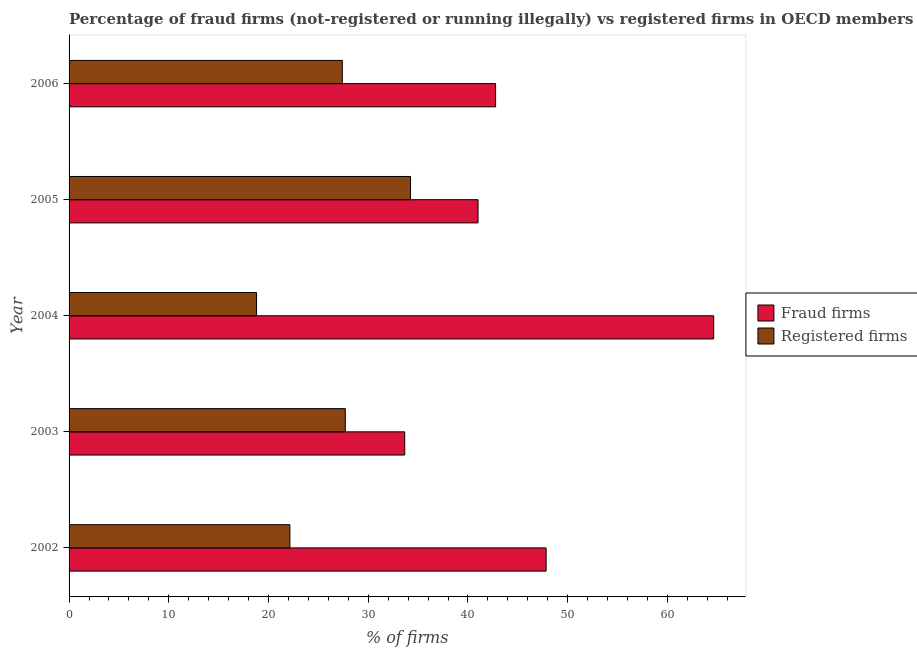Are the number of bars per tick equal to the number of legend labels?
Offer a very short reply. Yes. Are the number of bars on each tick of the Y-axis equal?
Keep it short and to the point. Yes. What is the label of the 5th group of bars from the top?
Provide a succinct answer. 2002. In how many cases, is the number of bars for a given year not equal to the number of legend labels?
Make the answer very short. 0. What is the percentage of fraud firms in 2005?
Offer a terse response. 41.01. Across all years, what is the maximum percentage of fraud firms?
Your answer should be very brief. 64.64. Across all years, what is the minimum percentage of registered firms?
Offer a very short reply. 18.8. What is the total percentage of registered firms in the graph?
Your answer should be compact. 130.28. What is the difference between the percentage of fraud firms in 2003 and that in 2004?
Your response must be concise. -30.98. What is the difference between the percentage of fraud firms in 2003 and the percentage of registered firms in 2005?
Make the answer very short. -0.58. What is the average percentage of fraud firms per year?
Your answer should be very brief. 45.98. In the year 2006, what is the difference between the percentage of registered firms and percentage of fraud firms?
Ensure brevity in your answer.  -15.37. What is the ratio of the percentage of fraud firms in 2005 to that in 2006?
Your answer should be compact. 0.96. Is the difference between the percentage of fraud firms in 2005 and 2006 greater than the difference between the percentage of registered firms in 2005 and 2006?
Make the answer very short. No. What is the difference between the highest and the second highest percentage of fraud firms?
Your answer should be very brief. 16.8. What is the difference between the highest and the lowest percentage of fraud firms?
Provide a short and direct response. 30.98. Is the sum of the percentage of registered firms in 2003 and 2006 greater than the maximum percentage of fraud firms across all years?
Your answer should be compact. No. What does the 2nd bar from the top in 2004 represents?
Make the answer very short. Fraud firms. What does the 2nd bar from the bottom in 2005 represents?
Your answer should be compact. Registered firms. Are all the bars in the graph horizontal?
Your answer should be compact. Yes. How many years are there in the graph?
Provide a short and direct response. 5. What is the difference between two consecutive major ticks on the X-axis?
Your answer should be very brief. 10. Are the values on the major ticks of X-axis written in scientific E-notation?
Keep it short and to the point. No. Does the graph contain any zero values?
Offer a very short reply. No. Does the graph contain grids?
Make the answer very short. No. Where does the legend appear in the graph?
Give a very brief answer. Center right. How many legend labels are there?
Give a very brief answer. 2. How are the legend labels stacked?
Give a very brief answer. Vertical. What is the title of the graph?
Keep it short and to the point. Percentage of fraud firms (not-registered or running illegally) vs registered firms in OECD members. Does "Exports of goods" appear as one of the legend labels in the graph?
Provide a short and direct response. No. What is the label or title of the X-axis?
Give a very brief answer. % of firms. What is the label or title of the Y-axis?
Make the answer very short. Year. What is the % of firms of Fraud firms in 2002?
Keep it short and to the point. 47.84. What is the % of firms in Registered firms in 2002?
Your answer should be very brief. 22.14. What is the % of firms of Fraud firms in 2003?
Your answer should be compact. 33.66. What is the % of firms in Registered firms in 2003?
Keep it short and to the point. 27.7. What is the % of firms in Fraud firms in 2004?
Offer a terse response. 64.64. What is the % of firms in Registered firms in 2004?
Offer a very short reply. 18.8. What is the % of firms in Fraud firms in 2005?
Your answer should be very brief. 41.01. What is the % of firms in Registered firms in 2005?
Ensure brevity in your answer.  34.24. What is the % of firms of Fraud firms in 2006?
Your response must be concise. 42.77. What is the % of firms of Registered firms in 2006?
Your answer should be compact. 27.4. Across all years, what is the maximum % of firms in Fraud firms?
Give a very brief answer. 64.64. Across all years, what is the maximum % of firms of Registered firms?
Ensure brevity in your answer.  34.24. Across all years, what is the minimum % of firms of Fraud firms?
Your answer should be compact. 33.66. Across all years, what is the minimum % of firms in Registered firms?
Give a very brief answer. 18.8. What is the total % of firms in Fraud firms in the graph?
Your answer should be very brief. 229.92. What is the total % of firms of Registered firms in the graph?
Keep it short and to the point. 130.28. What is the difference between the % of firms of Fraud firms in 2002 and that in 2003?
Provide a short and direct response. 14.18. What is the difference between the % of firms in Registered firms in 2002 and that in 2003?
Your response must be concise. -5.56. What is the difference between the % of firms of Fraud firms in 2002 and that in 2004?
Provide a short and direct response. -16.8. What is the difference between the % of firms in Registered firms in 2002 and that in 2004?
Make the answer very short. 3.34. What is the difference between the % of firms of Fraud firms in 2002 and that in 2005?
Your answer should be very brief. 6.83. What is the difference between the % of firms in Registered firms in 2002 and that in 2005?
Provide a succinct answer. -12.1. What is the difference between the % of firms of Fraud firms in 2002 and that in 2006?
Keep it short and to the point. 5.07. What is the difference between the % of firms of Registered firms in 2002 and that in 2006?
Your answer should be very brief. -5.26. What is the difference between the % of firms of Fraud firms in 2003 and that in 2004?
Provide a succinct answer. -30.98. What is the difference between the % of firms of Registered firms in 2003 and that in 2004?
Your answer should be very brief. 8.9. What is the difference between the % of firms of Fraud firms in 2003 and that in 2005?
Your answer should be very brief. -7.35. What is the difference between the % of firms in Registered firms in 2003 and that in 2005?
Offer a very short reply. -6.54. What is the difference between the % of firms in Fraud firms in 2003 and that in 2006?
Give a very brief answer. -9.11. What is the difference between the % of firms of Registered firms in 2003 and that in 2006?
Make the answer very short. 0.3. What is the difference between the % of firms in Fraud firms in 2004 and that in 2005?
Your answer should be very brief. 23.63. What is the difference between the % of firms in Registered firms in 2004 and that in 2005?
Offer a very short reply. -15.44. What is the difference between the % of firms in Fraud firms in 2004 and that in 2006?
Ensure brevity in your answer.  21.87. What is the difference between the % of firms in Registered firms in 2004 and that in 2006?
Provide a short and direct response. -8.6. What is the difference between the % of firms of Fraud firms in 2005 and that in 2006?
Make the answer very short. -1.76. What is the difference between the % of firms of Registered firms in 2005 and that in 2006?
Give a very brief answer. 6.84. What is the difference between the % of firms in Fraud firms in 2002 and the % of firms in Registered firms in 2003?
Offer a very short reply. 20.14. What is the difference between the % of firms of Fraud firms in 2002 and the % of firms of Registered firms in 2004?
Your response must be concise. 29.04. What is the difference between the % of firms of Fraud firms in 2002 and the % of firms of Registered firms in 2005?
Make the answer very short. 13.6. What is the difference between the % of firms in Fraud firms in 2002 and the % of firms in Registered firms in 2006?
Your answer should be very brief. 20.44. What is the difference between the % of firms in Fraud firms in 2003 and the % of firms in Registered firms in 2004?
Your answer should be very brief. 14.86. What is the difference between the % of firms of Fraud firms in 2003 and the % of firms of Registered firms in 2005?
Provide a succinct answer. -0.58. What is the difference between the % of firms in Fraud firms in 2003 and the % of firms in Registered firms in 2006?
Keep it short and to the point. 6.26. What is the difference between the % of firms in Fraud firms in 2004 and the % of firms in Registered firms in 2005?
Your answer should be compact. 30.4. What is the difference between the % of firms of Fraud firms in 2004 and the % of firms of Registered firms in 2006?
Your answer should be compact. 37.24. What is the difference between the % of firms in Fraud firms in 2005 and the % of firms in Registered firms in 2006?
Make the answer very short. 13.61. What is the average % of firms of Fraud firms per year?
Make the answer very short. 45.98. What is the average % of firms in Registered firms per year?
Keep it short and to the point. 26.06. In the year 2002, what is the difference between the % of firms in Fraud firms and % of firms in Registered firms?
Offer a terse response. 25.69. In the year 2003, what is the difference between the % of firms in Fraud firms and % of firms in Registered firms?
Provide a succinct answer. 5.96. In the year 2004, what is the difference between the % of firms of Fraud firms and % of firms of Registered firms?
Give a very brief answer. 45.84. In the year 2005, what is the difference between the % of firms in Fraud firms and % of firms in Registered firms?
Give a very brief answer. 6.77. In the year 2006, what is the difference between the % of firms in Fraud firms and % of firms in Registered firms?
Provide a short and direct response. 15.37. What is the ratio of the % of firms in Fraud firms in 2002 to that in 2003?
Make the answer very short. 1.42. What is the ratio of the % of firms of Registered firms in 2002 to that in 2003?
Offer a terse response. 0.8. What is the ratio of the % of firms of Fraud firms in 2002 to that in 2004?
Provide a succinct answer. 0.74. What is the ratio of the % of firms of Registered firms in 2002 to that in 2004?
Offer a terse response. 1.18. What is the ratio of the % of firms of Fraud firms in 2002 to that in 2005?
Offer a very short reply. 1.17. What is the ratio of the % of firms in Registered firms in 2002 to that in 2005?
Offer a very short reply. 0.65. What is the ratio of the % of firms of Fraud firms in 2002 to that in 2006?
Make the answer very short. 1.12. What is the ratio of the % of firms of Registered firms in 2002 to that in 2006?
Make the answer very short. 0.81. What is the ratio of the % of firms in Fraud firms in 2003 to that in 2004?
Offer a terse response. 0.52. What is the ratio of the % of firms in Registered firms in 2003 to that in 2004?
Your answer should be compact. 1.47. What is the ratio of the % of firms in Fraud firms in 2003 to that in 2005?
Your response must be concise. 0.82. What is the ratio of the % of firms in Registered firms in 2003 to that in 2005?
Your answer should be very brief. 0.81. What is the ratio of the % of firms of Fraud firms in 2003 to that in 2006?
Your answer should be compact. 0.79. What is the ratio of the % of firms in Registered firms in 2003 to that in 2006?
Make the answer very short. 1.01. What is the ratio of the % of firms in Fraud firms in 2004 to that in 2005?
Provide a short and direct response. 1.58. What is the ratio of the % of firms of Registered firms in 2004 to that in 2005?
Provide a short and direct response. 0.55. What is the ratio of the % of firms of Fraud firms in 2004 to that in 2006?
Your answer should be very brief. 1.51. What is the ratio of the % of firms in Registered firms in 2004 to that in 2006?
Offer a very short reply. 0.69. What is the ratio of the % of firms of Fraud firms in 2005 to that in 2006?
Provide a succinct answer. 0.96. What is the ratio of the % of firms of Registered firms in 2005 to that in 2006?
Provide a succinct answer. 1.25. What is the difference between the highest and the second highest % of firms in Fraud firms?
Provide a succinct answer. 16.8. What is the difference between the highest and the second highest % of firms of Registered firms?
Provide a short and direct response. 6.54. What is the difference between the highest and the lowest % of firms in Fraud firms?
Offer a terse response. 30.98. What is the difference between the highest and the lowest % of firms in Registered firms?
Give a very brief answer. 15.44. 